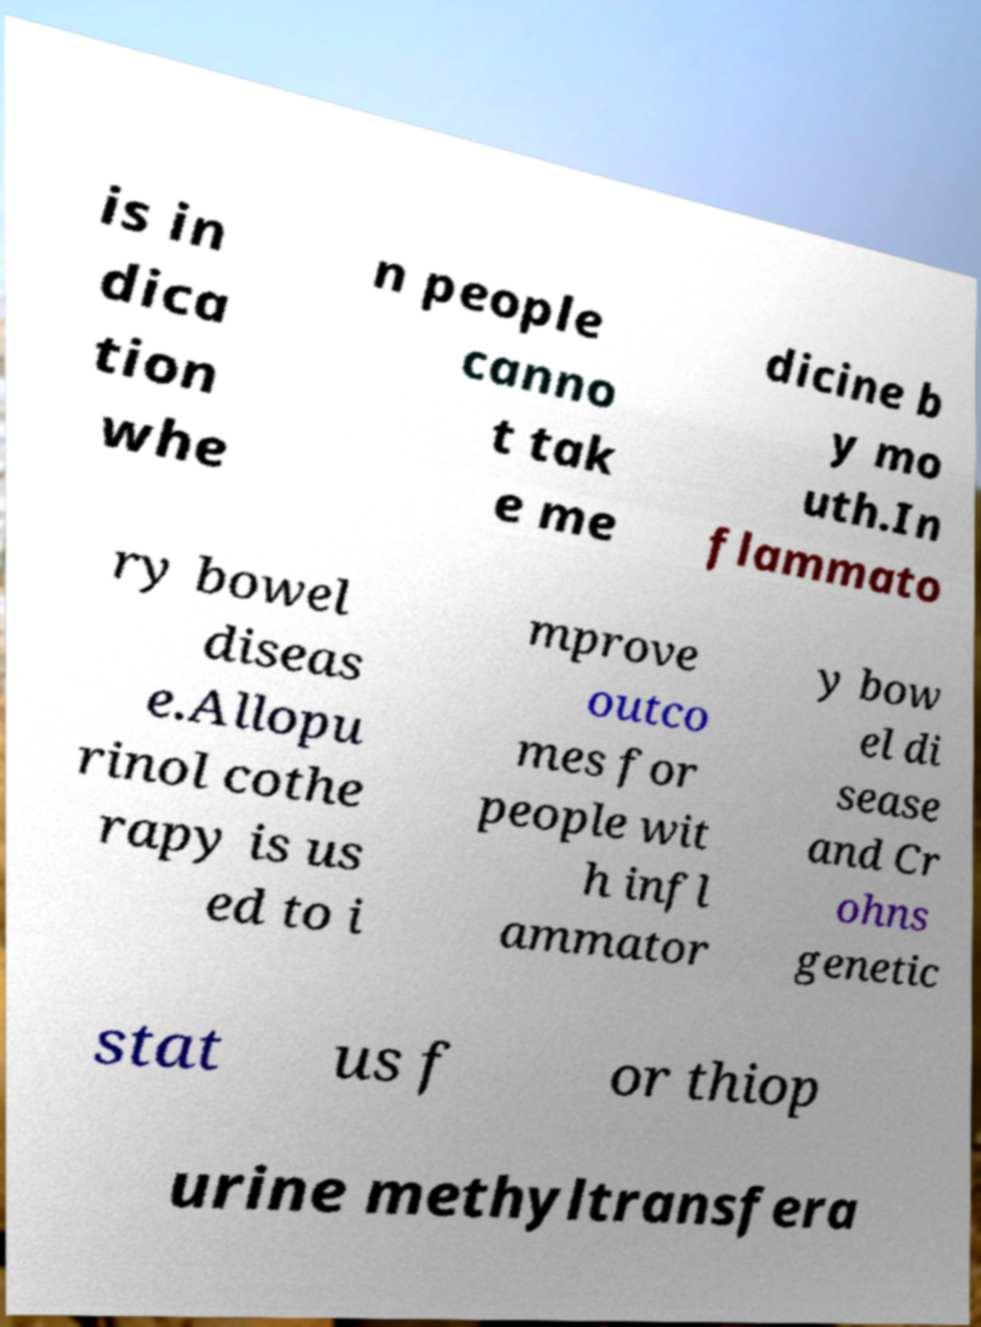Can you read and provide the text displayed in the image?This photo seems to have some interesting text. Can you extract and type it out for me? is in dica tion whe n people canno t tak e me dicine b y mo uth.In flammato ry bowel diseas e.Allopu rinol cothe rapy is us ed to i mprove outco mes for people wit h infl ammator y bow el di sease and Cr ohns genetic stat us f or thiop urine methyltransfera 